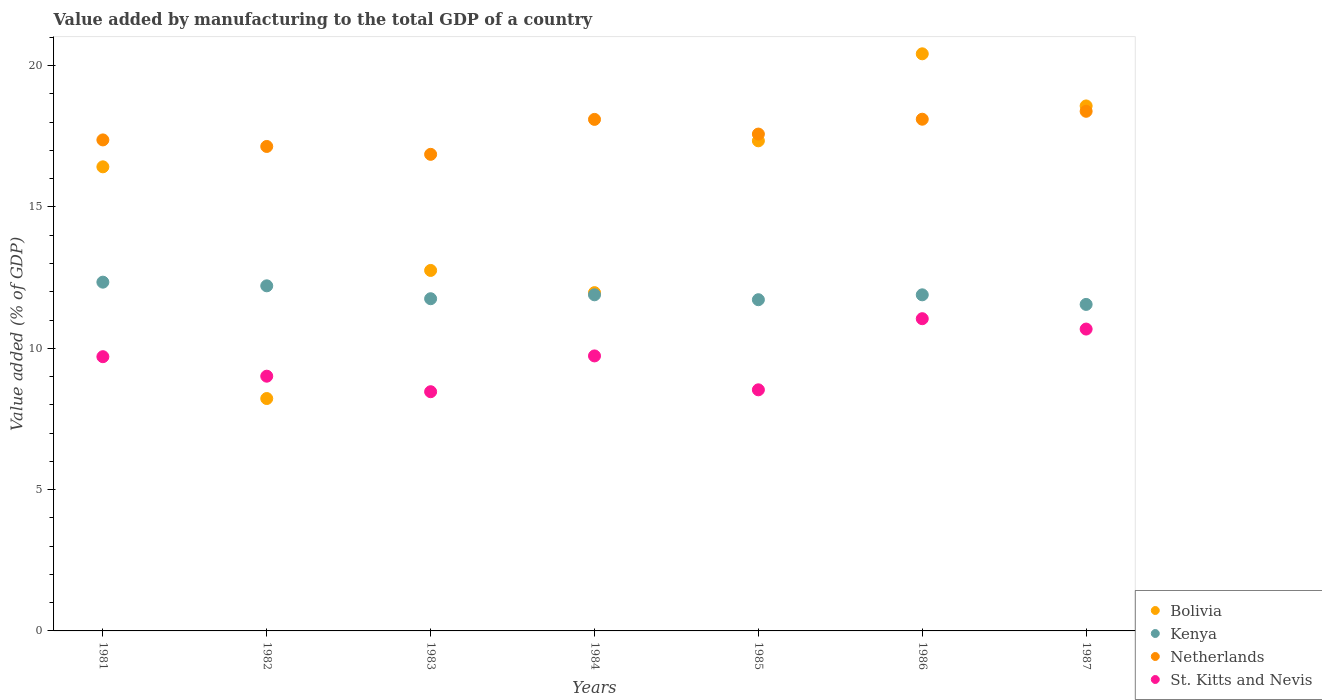How many different coloured dotlines are there?
Give a very brief answer. 4. Is the number of dotlines equal to the number of legend labels?
Make the answer very short. Yes. What is the value added by manufacturing to the total GDP in Kenya in 1986?
Offer a terse response. 11.89. Across all years, what is the maximum value added by manufacturing to the total GDP in Kenya?
Your answer should be compact. 12.34. Across all years, what is the minimum value added by manufacturing to the total GDP in Bolivia?
Offer a very short reply. 8.22. In which year was the value added by manufacturing to the total GDP in Netherlands maximum?
Your response must be concise. 1987. In which year was the value added by manufacturing to the total GDP in St. Kitts and Nevis minimum?
Ensure brevity in your answer.  1983. What is the total value added by manufacturing to the total GDP in Kenya in the graph?
Ensure brevity in your answer.  83.36. What is the difference between the value added by manufacturing to the total GDP in Netherlands in 1981 and that in 1982?
Your answer should be compact. 0.23. What is the difference between the value added by manufacturing to the total GDP in St. Kitts and Nevis in 1983 and the value added by manufacturing to the total GDP in Netherlands in 1986?
Offer a very short reply. -9.64. What is the average value added by manufacturing to the total GDP in Bolivia per year?
Your answer should be compact. 15.1. In the year 1983, what is the difference between the value added by manufacturing to the total GDP in Netherlands and value added by manufacturing to the total GDP in Kenya?
Your response must be concise. 5.11. In how many years, is the value added by manufacturing to the total GDP in Netherlands greater than 5 %?
Your answer should be very brief. 7. What is the ratio of the value added by manufacturing to the total GDP in Kenya in 1983 to that in 1985?
Give a very brief answer. 1. What is the difference between the highest and the second highest value added by manufacturing to the total GDP in Netherlands?
Keep it short and to the point. 0.28. What is the difference between the highest and the lowest value added by manufacturing to the total GDP in Bolivia?
Offer a terse response. 12.2. In how many years, is the value added by manufacturing to the total GDP in Kenya greater than the average value added by manufacturing to the total GDP in Kenya taken over all years?
Give a very brief answer. 2. Is it the case that in every year, the sum of the value added by manufacturing to the total GDP in St. Kitts and Nevis and value added by manufacturing to the total GDP in Bolivia  is greater than the sum of value added by manufacturing to the total GDP in Kenya and value added by manufacturing to the total GDP in Netherlands?
Provide a short and direct response. No. How many dotlines are there?
Provide a short and direct response. 4. How many years are there in the graph?
Offer a terse response. 7. Are the values on the major ticks of Y-axis written in scientific E-notation?
Offer a terse response. No. Does the graph contain any zero values?
Ensure brevity in your answer.  No. How many legend labels are there?
Provide a succinct answer. 4. What is the title of the graph?
Keep it short and to the point. Value added by manufacturing to the total GDP of a country. What is the label or title of the X-axis?
Give a very brief answer. Years. What is the label or title of the Y-axis?
Provide a succinct answer. Value added (% of GDP). What is the Value added (% of GDP) in Bolivia in 1981?
Provide a succinct answer. 16.42. What is the Value added (% of GDP) of Kenya in 1981?
Offer a terse response. 12.34. What is the Value added (% of GDP) in Netherlands in 1981?
Offer a very short reply. 17.37. What is the Value added (% of GDP) of St. Kitts and Nevis in 1981?
Your answer should be very brief. 9.7. What is the Value added (% of GDP) of Bolivia in 1982?
Ensure brevity in your answer.  8.22. What is the Value added (% of GDP) of Kenya in 1982?
Your answer should be very brief. 12.21. What is the Value added (% of GDP) of Netherlands in 1982?
Give a very brief answer. 17.14. What is the Value added (% of GDP) of St. Kitts and Nevis in 1982?
Provide a succinct answer. 9.01. What is the Value added (% of GDP) of Bolivia in 1983?
Provide a succinct answer. 12.75. What is the Value added (% of GDP) in Kenya in 1983?
Make the answer very short. 11.75. What is the Value added (% of GDP) of Netherlands in 1983?
Give a very brief answer. 16.86. What is the Value added (% of GDP) of St. Kitts and Nevis in 1983?
Your response must be concise. 8.46. What is the Value added (% of GDP) of Bolivia in 1984?
Offer a very short reply. 11.97. What is the Value added (% of GDP) in Kenya in 1984?
Your answer should be very brief. 11.89. What is the Value added (% of GDP) in Netherlands in 1984?
Make the answer very short. 18.1. What is the Value added (% of GDP) in St. Kitts and Nevis in 1984?
Your answer should be compact. 9.73. What is the Value added (% of GDP) of Bolivia in 1985?
Keep it short and to the point. 17.34. What is the Value added (% of GDP) of Kenya in 1985?
Give a very brief answer. 11.72. What is the Value added (% of GDP) of Netherlands in 1985?
Provide a succinct answer. 17.58. What is the Value added (% of GDP) in St. Kitts and Nevis in 1985?
Keep it short and to the point. 8.53. What is the Value added (% of GDP) in Bolivia in 1986?
Offer a very short reply. 20.42. What is the Value added (% of GDP) of Kenya in 1986?
Your answer should be very brief. 11.89. What is the Value added (% of GDP) in Netherlands in 1986?
Keep it short and to the point. 18.1. What is the Value added (% of GDP) in St. Kitts and Nevis in 1986?
Give a very brief answer. 11.05. What is the Value added (% of GDP) of Bolivia in 1987?
Offer a terse response. 18.57. What is the Value added (% of GDP) in Kenya in 1987?
Give a very brief answer. 11.55. What is the Value added (% of GDP) of Netherlands in 1987?
Ensure brevity in your answer.  18.38. What is the Value added (% of GDP) in St. Kitts and Nevis in 1987?
Your answer should be very brief. 10.68. Across all years, what is the maximum Value added (% of GDP) in Bolivia?
Your answer should be very brief. 20.42. Across all years, what is the maximum Value added (% of GDP) of Kenya?
Your answer should be very brief. 12.34. Across all years, what is the maximum Value added (% of GDP) in Netherlands?
Make the answer very short. 18.38. Across all years, what is the maximum Value added (% of GDP) of St. Kitts and Nevis?
Provide a succinct answer. 11.05. Across all years, what is the minimum Value added (% of GDP) of Bolivia?
Provide a succinct answer. 8.22. Across all years, what is the minimum Value added (% of GDP) in Kenya?
Offer a terse response. 11.55. Across all years, what is the minimum Value added (% of GDP) in Netherlands?
Your response must be concise. 16.86. Across all years, what is the minimum Value added (% of GDP) of St. Kitts and Nevis?
Your answer should be compact. 8.46. What is the total Value added (% of GDP) of Bolivia in the graph?
Your answer should be compact. 105.7. What is the total Value added (% of GDP) of Kenya in the graph?
Offer a very short reply. 83.36. What is the total Value added (% of GDP) in Netherlands in the graph?
Offer a terse response. 123.54. What is the total Value added (% of GDP) of St. Kitts and Nevis in the graph?
Offer a very short reply. 67.16. What is the difference between the Value added (% of GDP) in Bolivia in 1981 and that in 1982?
Your response must be concise. 8.2. What is the difference between the Value added (% of GDP) in Kenya in 1981 and that in 1982?
Provide a succinct answer. 0.13. What is the difference between the Value added (% of GDP) in Netherlands in 1981 and that in 1982?
Your response must be concise. 0.23. What is the difference between the Value added (% of GDP) of St. Kitts and Nevis in 1981 and that in 1982?
Offer a very short reply. 0.69. What is the difference between the Value added (% of GDP) of Bolivia in 1981 and that in 1983?
Your response must be concise. 3.67. What is the difference between the Value added (% of GDP) of Kenya in 1981 and that in 1983?
Provide a short and direct response. 0.59. What is the difference between the Value added (% of GDP) in Netherlands in 1981 and that in 1983?
Offer a very short reply. 0.51. What is the difference between the Value added (% of GDP) of St. Kitts and Nevis in 1981 and that in 1983?
Your answer should be compact. 1.24. What is the difference between the Value added (% of GDP) in Bolivia in 1981 and that in 1984?
Keep it short and to the point. 4.45. What is the difference between the Value added (% of GDP) in Kenya in 1981 and that in 1984?
Make the answer very short. 0.45. What is the difference between the Value added (% of GDP) in Netherlands in 1981 and that in 1984?
Your answer should be compact. -0.73. What is the difference between the Value added (% of GDP) in St. Kitts and Nevis in 1981 and that in 1984?
Ensure brevity in your answer.  -0.03. What is the difference between the Value added (% of GDP) in Bolivia in 1981 and that in 1985?
Provide a succinct answer. -0.92. What is the difference between the Value added (% of GDP) in Kenya in 1981 and that in 1985?
Your response must be concise. 0.62. What is the difference between the Value added (% of GDP) of Netherlands in 1981 and that in 1985?
Give a very brief answer. -0.21. What is the difference between the Value added (% of GDP) of St. Kitts and Nevis in 1981 and that in 1985?
Provide a succinct answer. 1.17. What is the difference between the Value added (% of GDP) of Bolivia in 1981 and that in 1986?
Your answer should be very brief. -4. What is the difference between the Value added (% of GDP) in Kenya in 1981 and that in 1986?
Ensure brevity in your answer.  0.45. What is the difference between the Value added (% of GDP) of Netherlands in 1981 and that in 1986?
Your answer should be very brief. -0.73. What is the difference between the Value added (% of GDP) of St. Kitts and Nevis in 1981 and that in 1986?
Your response must be concise. -1.34. What is the difference between the Value added (% of GDP) in Bolivia in 1981 and that in 1987?
Your answer should be very brief. -2.15. What is the difference between the Value added (% of GDP) of Kenya in 1981 and that in 1987?
Ensure brevity in your answer.  0.79. What is the difference between the Value added (% of GDP) of Netherlands in 1981 and that in 1987?
Offer a very short reply. -1.01. What is the difference between the Value added (% of GDP) in St. Kitts and Nevis in 1981 and that in 1987?
Provide a short and direct response. -0.98. What is the difference between the Value added (% of GDP) in Bolivia in 1982 and that in 1983?
Give a very brief answer. -4.53. What is the difference between the Value added (% of GDP) in Kenya in 1982 and that in 1983?
Ensure brevity in your answer.  0.46. What is the difference between the Value added (% of GDP) in Netherlands in 1982 and that in 1983?
Offer a terse response. 0.28. What is the difference between the Value added (% of GDP) in St. Kitts and Nevis in 1982 and that in 1983?
Make the answer very short. 0.55. What is the difference between the Value added (% of GDP) of Bolivia in 1982 and that in 1984?
Provide a succinct answer. -3.75. What is the difference between the Value added (% of GDP) in Kenya in 1982 and that in 1984?
Offer a very short reply. 0.32. What is the difference between the Value added (% of GDP) in Netherlands in 1982 and that in 1984?
Your answer should be very brief. -0.96. What is the difference between the Value added (% of GDP) in St. Kitts and Nevis in 1982 and that in 1984?
Your response must be concise. -0.72. What is the difference between the Value added (% of GDP) of Bolivia in 1982 and that in 1985?
Your response must be concise. -9.12. What is the difference between the Value added (% of GDP) in Kenya in 1982 and that in 1985?
Offer a very short reply. 0.49. What is the difference between the Value added (% of GDP) in Netherlands in 1982 and that in 1985?
Your response must be concise. -0.44. What is the difference between the Value added (% of GDP) of St. Kitts and Nevis in 1982 and that in 1985?
Make the answer very short. 0.48. What is the difference between the Value added (% of GDP) in Bolivia in 1982 and that in 1986?
Provide a short and direct response. -12.2. What is the difference between the Value added (% of GDP) of Kenya in 1982 and that in 1986?
Provide a short and direct response. 0.32. What is the difference between the Value added (% of GDP) in Netherlands in 1982 and that in 1986?
Your answer should be very brief. -0.96. What is the difference between the Value added (% of GDP) in St. Kitts and Nevis in 1982 and that in 1986?
Your answer should be compact. -2.03. What is the difference between the Value added (% of GDP) in Bolivia in 1982 and that in 1987?
Your answer should be very brief. -10.35. What is the difference between the Value added (% of GDP) in Kenya in 1982 and that in 1987?
Provide a succinct answer. 0.66. What is the difference between the Value added (% of GDP) of Netherlands in 1982 and that in 1987?
Your response must be concise. -1.24. What is the difference between the Value added (% of GDP) in St. Kitts and Nevis in 1982 and that in 1987?
Offer a very short reply. -1.67. What is the difference between the Value added (% of GDP) in Bolivia in 1983 and that in 1984?
Make the answer very short. 0.79. What is the difference between the Value added (% of GDP) in Kenya in 1983 and that in 1984?
Keep it short and to the point. -0.14. What is the difference between the Value added (% of GDP) in Netherlands in 1983 and that in 1984?
Provide a short and direct response. -1.24. What is the difference between the Value added (% of GDP) of St. Kitts and Nevis in 1983 and that in 1984?
Offer a terse response. -1.27. What is the difference between the Value added (% of GDP) in Bolivia in 1983 and that in 1985?
Your answer should be very brief. -4.59. What is the difference between the Value added (% of GDP) in Kenya in 1983 and that in 1985?
Keep it short and to the point. 0.04. What is the difference between the Value added (% of GDP) of Netherlands in 1983 and that in 1985?
Give a very brief answer. -0.72. What is the difference between the Value added (% of GDP) of St. Kitts and Nevis in 1983 and that in 1985?
Keep it short and to the point. -0.07. What is the difference between the Value added (% of GDP) of Bolivia in 1983 and that in 1986?
Your answer should be very brief. -7.66. What is the difference between the Value added (% of GDP) of Kenya in 1983 and that in 1986?
Provide a short and direct response. -0.14. What is the difference between the Value added (% of GDP) of Netherlands in 1983 and that in 1986?
Provide a short and direct response. -1.24. What is the difference between the Value added (% of GDP) of St. Kitts and Nevis in 1983 and that in 1986?
Make the answer very short. -2.58. What is the difference between the Value added (% of GDP) in Bolivia in 1983 and that in 1987?
Keep it short and to the point. -5.82. What is the difference between the Value added (% of GDP) of Kenya in 1983 and that in 1987?
Make the answer very short. 0.2. What is the difference between the Value added (% of GDP) of Netherlands in 1983 and that in 1987?
Make the answer very short. -1.52. What is the difference between the Value added (% of GDP) of St. Kitts and Nevis in 1983 and that in 1987?
Provide a short and direct response. -2.22. What is the difference between the Value added (% of GDP) in Bolivia in 1984 and that in 1985?
Provide a short and direct response. -5.37. What is the difference between the Value added (% of GDP) of Kenya in 1984 and that in 1985?
Keep it short and to the point. 0.17. What is the difference between the Value added (% of GDP) of Netherlands in 1984 and that in 1985?
Provide a succinct answer. 0.52. What is the difference between the Value added (% of GDP) of St. Kitts and Nevis in 1984 and that in 1985?
Provide a succinct answer. 1.2. What is the difference between the Value added (% of GDP) in Bolivia in 1984 and that in 1986?
Provide a succinct answer. -8.45. What is the difference between the Value added (% of GDP) in Kenya in 1984 and that in 1986?
Provide a succinct answer. 0. What is the difference between the Value added (% of GDP) of Netherlands in 1984 and that in 1986?
Give a very brief answer. -0.01. What is the difference between the Value added (% of GDP) of St. Kitts and Nevis in 1984 and that in 1986?
Ensure brevity in your answer.  -1.32. What is the difference between the Value added (% of GDP) in Bolivia in 1984 and that in 1987?
Your answer should be compact. -6.61. What is the difference between the Value added (% of GDP) of Kenya in 1984 and that in 1987?
Make the answer very short. 0.34. What is the difference between the Value added (% of GDP) of Netherlands in 1984 and that in 1987?
Your answer should be very brief. -0.29. What is the difference between the Value added (% of GDP) of St. Kitts and Nevis in 1984 and that in 1987?
Give a very brief answer. -0.95. What is the difference between the Value added (% of GDP) in Bolivia in 1985 and that in 1986?
Ensure brevity in your answer.  -3.08. What is the difference between the Value added (% of GDP) in Kenya in 1985 and that in 1986?
Offer a very short reply. -0.17. What is the difference between the Value added (% of GDP) in Netherlands in 1985 and that in 1986?
Your response must be concise. -0.53. What is the difference between the Value added (% of GDP) of St. Kitts and Nevis in 1985 and that in 1986?
Your response must be concise. -2.52. What is the difference between the Value added (% of GDP) of Bolivia in 1985 and that in 1987?
Provide a short and direct response. -1.23. What is the difference between the Value added (% of GDP) in Kenya in 1985 and that in 1987?
Provide a succinct answer. 0.17. What is the difference between the Value added (% of GDP) of Netherlands in 1985 and that in 1987?
Offer a terse response. -0.81. What is the difference between the Value added (% of GDP) of St. Kitts and Nevis in 1985 and that in 1987?
Your response must be concise. -2.15. What is the difference between the Value added (% of GDP) of Bolivia in 1986 and that in 1987?
Give a very brief answer. 1.84. What is the difference between the Value added (% of GDP) in Kenya in 1986 and that in 1987?
Ensure brevity in your answer.  0.34. What is the difference between the Value added (% of GDP) of Netherlands in 1986 and that in 1987?
Keep it short and to the point. -0.28. What is the difference between the Value added (% of GDP) in St. Kitts and Nevis in 1986 and that in 1987?
Keep it short and to the point. 0.37. What is the difference between the Value added (% of GDP) of Bolivia in 1981 and the Value added (% of GDP) of Kenya in 1982?
Ensure brevity in your answer.  4.21. What is the difference between the Value added (% of GDP) in Bolivia in 1981 and the Value added (% of GDP) in Netherlands in 1982?
Your answer should be very brief. -0.72. What is the difference between the Value added (% of GDP) in Bolivia in 1981 and the Value added (% of GDP) in St. Kitts and Nevis in 1982?
Your answer should be compact. 7.41. What is the difference between the Value added (% of GDP) of Kenya in 1981 and the Value added (% of GDP) of Netherlands in 1982?
Provide a succinct answer. -4.8. What is the difference between the Value added (% of GDP) in Kenya in 1981 and the Value added (% of GDP) in St. Kitts and Nevis in 1982?
Your answer should be compact. 3.33. What is the difference between the Value added (% of GDP) in Netherlands in 1981 and the Value added (% of GDP) in St. Kitts and Nevis in 1982?
Ensure brevity in your answer.  8.36. What is the difference between the Value added (% of GDP) in Bolivia in 1981 and the Value added (% of GDP) in Kenya in 1983?
Make the answer very short. 4.67. What is the difference between the Value added (% of GDP) in Bolivia in 1981 and the Value added (% of GDP) in Netherlands in 1983?
Give a very brief answer. -0.44. What is the difference between the Value added (% of GDP) in Bolivia in 1981 and the Value added (% of GDP) in St. Kitts and Nevis in 1983?
Ensure brevity in your answer.  7.96. What is the difference between the Value added (% of GDP) of Kenya in 1981 and the Value added (% of GDP) of Netherlands in 1983?
Give a very brief answer. -4.52. What is the difference between the Value added (% of GDP) of Kenya in 1981 and the Value added (% of GDP) of St. Kitts and Nevis in 1983?
Your answer should be compact. 3.88. What is the difference between the Value added (% of GDP) of Netherlands in 1981 and the Value added (% of GDP) of St. Kitts and Nevis in 1983?
Offer a terse response. 8.91. What is the difference between the Value added (% of GDP) of Bolivia in 1981 and the Value added (% of GDP) of Kenya in 1984?
Your response must be concise. 4.53. What is the difference between the Value added (% of GDP) of Bolivia in 1981 and the Value added (% of GDP) of Netherlands in 1984?
Make the answer very short. -1.68. What is the difference between the Value added (% of GDP) in Bolivia in 1981 and the Value added (% of GDP) in St. Kitts and Nevis in 1984?
Provide a succinct answer. 6.69. What is the difference between the Value added (% of GDP) of Kenya in 1981 and the Value added (% of GDP) of Netherlands in 1984?
Provide a short and direct response. -5.76. What is the difference between the Value added (% of GDP) of Kenya in 1981 and the Value added (% of GDP) of St. Kitts and Nevis in 1984?
Offer a terse response. 2.61. What is the difference between the Value added (% of GDP) of Netherlands in 1981 and the Value added (% of GDP) of St. Kitts and Nevis in 1984?
Your answer should be compact. 7.64. What is the difference between the Value added (% of GDP) in Bolivia in 1981 and the Value added (% of GDP) in Kenya in 1985?
Give a very brief answer. 4.7. What is the difference between the Value added (% of GDP) in Bolivia in 1981 and the Value added (% of GDP) in Netherlands in 1985?
Your response must be concise. -1.16. What is the difference between the Value added (% of GDP) of Bolivia in 1981 and the Value added (% of GDP) of St. Kitts and Nevis in 1985?
Provide a succinct answer. 7.89. What is the difference between the Value added (% of GDP) in Kenya in 1981 and the Value added (% of GDP) in Netherlands in 1985?
Provide a short and direct response. -5.24. What is the difference between the Value added (% of GDP) of Kenya in 1981 and the Value added (% of GDP) of St. Kitts and Nevis in 1985?
Your answer should be very brief. 3.81. What is the difference between the Value added (% of GDP) of Netherlands in 1981 and the Value added (% of GDP) of St. Kitts and Nevis in 1985?
Make the answer very short. 8.84. What is the difference between the Value added (% of GDP) of Bolivia in 1981 and the Value added (% of GDP) of Kenya in 1986?
Your answer should be very brief. 4.53. What is the difference between the Value added (% of GDP) in Bolivia in 1981 and the Value added (% of GDP) in Netherlands in 1986?
Your answer should be very brief. -1.68. What is the difference between the Value added (% of GDP) of Bolivia in 1981 and the Value added (% of GDP) of St. Kitts and Nevis in 1986?
Make the answer very short. 5.37. What is the difference between the Value added (% of GDP) of Kenya in 1981 and the Value added (% of GDP) of Netherlands in 1986?
Make the answer very short. -5.76. What is the difference between the Value added (% of GDP) of Kenya in 1981 and the Value added (% of GDP) of St. Kitts and Nevis in 1986?
Provide a short and direct response. 1.29. What is the difference between the Value added (% of GDP) of Netherlands in 1981 and the Value added (% of GDP) of St. Kitts and Nevis in 1986?
Your answer should be very brief. 6.33. What is the difference between the Value added (% of GDP) in Bolivia in 1981 and the Value added (% of GDP) in Kenya in 1987?
Make the answer very short. 4.87. What is the difference between the Value added (% of GDP) in Bolivia in 1981 and the Value added (% of GDP) in Netherlands in 1987?
Keep it short and to the point. -1.96. What is the difference between the Value added (% of GDP) of Bolivia in 1981 and the Value added (% of GDP) of St. Kitts and Nevis in 1987?
Your answer should be very brief. 5.74. What is the difference between the Value added (% of GDP) in Kenya in 1981 and the Value added (% of GDP) in Netherlands in 1987?
Provide a succinct answer. -6.05. What is the difference between the Value added (% of GDP) of Kenya in 1981 and the Value added (% of GDP) of St. Kitts and Nevis in 1987?
Give a very brief answer. 1.66. What is the difference between the Value added (% of GDP) of Netherlands in 1981 and the Value added (% of GDP) of St. Kitts and Nevis in 1987?
Ensure brevity in your answer.  6.69. What is the difference between the Value added (% of GDP) of Bolivia in 1982 and the Value added (% of GDP) of Kenya in 1983?
Your answer should be compact. -3.53. What is the difference between the Value added (% of GDP) in Bolivia in 1982 and the Value added (% of GDP) in Netherlands in 1983?
Provide a short and direct response. -8.64. What is the difference between the Value added (% of GDP) in Bolivia in 1982 and the Value added (% of GDP) in St. Kitts and Nevis in 1983?
Give a very brief answer. -0.24. What is the difference between the Value added (% of GDP) in Kenya in 1982 and the Value added (% of GDP) in Netherlands in 1983?
Provide a short and direct response. -4.65. What is the difference between the Value added (% of GDP) in Kenya in 1982 and the Value added (% of GDP) in St. Kitts and Nevis in 1983?
Offer a very short reply. 3.75. What is the difference between the Value added (% of GDP) of Netherlands in 1982 and the Value added (% of GDP) of St. Kitts and Nevis in 1983?
Provide a succinct answer. 8.68. What is the difference between the Value added (% of GDP) of Bolivia in 1982 and the Value added (% of GDP) of Kenya in 1984?
Your answer should be very brief. -3.67. What is the difference between the Value added (% of GDP) of Bolivia in 1982 and the Value added (% of GDP) of Netherlands in 1984?
Ensure brevity in your answer.  -9.88. What is the difference between the Value added (% of GDP) of Bolivia in 1982 and the Value added (% of GDP) of St. Kitts and Nevis in 1984?
Provide a short and direct response. -1.51. What is the difference between the Value added (% of GDP) of Kenya in 1982 and the Value added (% of GDP) of Netherlands in 1984?
Provide a succinct answer. -5.89. What is the difference between the Value added (% of GDP) in Kenya in 1982 and the Value added (% of GDP) in St. Kitts and Nevis in 1984?
Offer a very short reply. 2.48. What is the difference between the Value added (% of GDP) of Netherlands in 1982 and the Value added (% of GDP) of St. Kitts and Nevis in 1984?
Provide a succinct answer. 7.41. What is the difference between the Value added (% of GDP) in Bolivia in 1982 and the Value added (% of GDP) in Kenya in 1985?
Provide a succinct answer. -3.5. What is the difference between the Value added (% of GDP) in Bolivia in 1982 and the Value added (% of GDP) in Netherlands in 1985?
Ensure brevity in your answer.  -9.36. What is the difference between the Value added (% of GDP) of Bolivia in 1982 and the Value added (% of GDP) of St. Kitts and Nevis in 1985?
Offer a very short reply. -0.31. What is the difference between the Value added (% of GDP) in Kenya in 1982 and the Value added (% of GDP) in Netherlands in 1985?
Your answer should be very brief. -5.37. What is the difference between the Value added (% of GDP) of Kenya in 1982 and the Value added (% of GDP) of St. Kitts and Nevis in 1985?
Ensure brevity in your answer.  3.68. What is the difference between the Value added (% of GDP) of Netherlands in 1982 and the Value added (% of GDP) of St. Kitts and Nevis in 1985?
Provide a succinct answer. 8.61. What is the difference between the Value added (% of GDP) in Bolivia in 1982 and the Value added (% of GDP) in Kenya in 1986?
Keep it short and to the point. -3.67. What is the difference between the Value added (% of GDP) of Bolivia in 1982 and the Value added (% of GDP) of Netherlands in 1986?
Your response must be concise. -9.88. What is the difference between the Value added (% of GDP) of Bolivia in 1982 and the Value added (% of GDP) of St. Kitts and Nevis in 1986?
Your response must be concise. -2.82. What is the difference between the Value added (% of GDP) of Kenya in 1982 and the Value added (% of GDP) of Netherlands in 1986?
Give a very brief answer. -5.89. What is the difference between the Value added (% of GDP) in Kenya in 1982 and the Value added (% of GDP) in St. Kitts and Nevis in 1986?
Your answer should be compact. 1.16. What is the difference between the Value added (% of GDP) in Netherlands in 1982 and the Value added (% of GDP) in St. Kitts and Nevis in 1986?
Offer a terse response. 6.09. What is the difference between the Value added (% of GDP) of Bolivia in 1982 and the Value added (% of GDP) of Kenya in 1987?
Offer a very short reply. -3.33. What is the difference between the Value added (% of GDP) in Bolivia in 1982 and the Value added (% of GDP) in Netherlands in 1987?
Offer a very short reply. -10.16. What is the difference between the Value added (% of GDP) in Bolivia in 1982 and the Value added (% of GDP) in St. Kitts and Nevis in 1987?
Your answer should be compact. -2.46. What is the difference between the Value added (% of GDP) of Kenya in 1982 and the Value added (% of GDP) of Netherlands in 1987?
Provide a succinct answer. -6.17. What is the difference between the Value added (% of GDP) in Kenya in 1982 and the Value added (% of GDP) in St. Kitts and Nevis in 1987?
Your answer should be compact. 1.53. What is the difference between the Value added (% of GDP) in Netherlands in 1982 and the Value added (% of GDP) in St. Kitts and Nevis in 1987?
Your answer should be very brief. 6.46. What is the difference between the Value added (% of GDP) in Bolivia in 1983 and the Value added (% of GDP) in Kenya in 1984?
Provide a short and direct response. 0.86. What is the difference between the Value added (% of GDP) in Bolivia in 1983 and the Value added (% of GDP) in Netherlands in 1984?
Provide a succinct answer. -5.34. What is the difference between the Value added (% of GDP) in Bolivia in 1983 and the Value added (% of GDP) in St. Kitts and Nevis in 1984?
Give a very brief answer. 3.02. What is the difference between the Value added (% of GDP) of Kenya in 1983 and the Value added (% of GDP) of Netherlands in 1984?
Provide a succinct answer. -6.34. What is the difference between the Value added (% of GDP) of Kenya in 1983 and the Value added (% of GDP) of St. Kitts and Nevis in 1984?
Make the answer very short. 2.02. What is the difference between the Value added (% of GDP) of Netherlands in 1983 and the Value added (% of GDP) of St. Kitts and Nevis in 1984?
Keep it short and to the point. 7.13. What is the difference between the Value added (% of GDP) in Bolivia in 1983 and the Value added (% of GDP) in Kenya in 1985?
Make the answer very short. 1.04. What is the difference between the Value added (% of GDP) of Bolivia in 1983 and the Value added (% of GDP) of Netherlands in 1985?
Provide a short and direct response. -4.82. What is the difference between the Value added (% of GDP) of Bolivia in 1983 and the Value added (% of GDP) of St. Kitts and Nevis in 1985?
Keep it short and to the point. 4.22. What is the difference between the Value added (% of GDP) of Kenya in 1983 and the Value added (% of GDP) of Netherlands in 1985?
Give a very brief answer. -5.83. What is the difference between the Value added (% of GDP) of Kenya in 1983 and the Value added (% of GDP) of St. Kitts and Nevis in 1985?
Your answer should be compact. 3.22. What is the difference between the Value added (% of GDP) in Netherlands in 1983 and the Value added (% of GDP) in St. Kitts and Nevis in 1985?
Ensure brevity in your answer.  8.33. What is the difference between the Value added (% of GDP) of Bolivia in 1983 and the Value added (% of GDP) of Kenya in 1986?
Your response must be concise. 0.86. What is the difference between the Value added (% of GDP) of Bolivia in 1983 and the Value added (% of GDP) of Netherlands in 1986?
Keep it short and to the point. -5.35. What is the difference between the Value added (% of GDP) in Bolivia in 1983 and the Value added (% of GDP) in St. Kitts and Nevis in 1986?
Give a very brief answer. 1.71. What is the difference between the Value added (% of GDP) in Kenya in 1983 and the Value added (% of GDP) in Netherlands in 1986?
Ensure brevity in your answer.  -6.35. What is the difference between the Value added (% of GDP) in Kenya in 1983 and the Value added (% of GDP) in St. Kitts and Nevis in 1986?
Keep it short and to the point. 0.71. What is the difference between the Value added (% of GDP) in Netherlands in 1983 and the Value added (% of GDP) in St. Kitts and Nevis in 1986?
Give a very brief answer. 5.82. What is the difference between the Value added (% of GDP) in Bolivia in 1983 and the Value added (% of GDP) in Kenya in 1987?
Offer a very short reply. 1.2. What is the difference between the Value added (% of GDP) in Bolivia in 1983 and the Value added (% of GDP) in Netherlands in 1987?
Ensure brevity in your answer.  -5.63. What is the difference between the Value added (% of GDP) of Bolivia in 1983 and the Value added (% of GDP) of St. Kitts and Nevis in 1987?
Your response must be concise. 2.07. What is the difference between the Value added (% of GDP) of Kenya in 1983 and the Value added (% of GDP) of Netherlands in 1987?
Make the answer very short. -6.63. What is the difference between the Value added (% of GDP) in Kenya in 1983 and the Value added (% of GDP) in St. Kitts and Nevis in 1987?
Provide a short and direct response. 1.07. What is the difference between the Value added (% of GDP) in Netherlands in 1983 and the Value added (% of GDP) in St. Kitts and Nevis in 1987?
Make the answer very short. 6.18. What is the difference between the Value added (% of GDP) in Bolivia in 1984 and the Value added (% of GDP) in Kenya in 1985?
Your answer should be compact. 0.25. What is the difference between the Value added (% of GDP) of Bolivia in 1984 and the Value added (% of GDP) of Netherlands in 1985?
Your answer should be compact. -5.61. What is the difference between the Value added (% of GDP) in Bolivia in 1984 and the Value added (% of GDP) in St. Kitts and Nevis in 1985?
Your answer should be compact. 3.44. What is the difference between the Value added (% of GDP) of Kenya in 1984 and the Value added (% of GDP) of Netherlands in 1985?
Ensure brevity in your answer.  -5.69. What is the difference between the Value added (% of GDP) of Kenya in 1984 and the Value added (% of GDP) of St. Kitts and Nevis in 1985?
Your response must be concise. 3.36. What is the difference between the Value added (% of GDP) in Netherlands in 1984 and the Value added (% of GDP) in St. Kitts and Nevis in 1985?
Keep it short and to the point. 9.57. What is the difference between the Value added (% of GDP) of Bolivia in 1984 and the Value added (% of GDP) of Kenya in 1986?
Give a very brief answer. 0.08. What is the difference between the Value added (% of GDP) of Bolivia in 1984 and the Value added (% of GDP) of Netherlands in 1986?
Your answer should be compact. -6.14. What is the difference between the Value added (% of GDP) of Bolivia in 1984 and the Value added (% of GDP) of St. Kitts and Nevis in 1986?
Ensure brevity in your answer.  0.92. What is the difference between the Value added (% of GDP) of Kenya in 1984 and the Value added (% of GDP) of Netherlands in 1986?
Your response must be concise. -6.21. What is the difference between the Value added (% of GDP) in Kenya in 1984 and the Value added (% of GDP) in St. Kitts and Nevis in 1986?
Provide a succinct answer. 0.85. What is the difference between the Value added (% of GDP) in Netherlands in 1984 and the Value added (% of GDP) in St. Kitts and Nevis in 1986?
Ensure brevity in your answer.  7.05. What is the difference between the Value added (% of GDP) of Bolivia in 1984 and the Value added (% of GDP) of Kenya in 1987?
Keep it short and to the point. 0.42. What is the difference between the Value added (% of GDP) of Bolivia in 1984 and the Value added (% of GDP) of Netherlands in 1987?
Your answer should be very brief. -6.42. What is the difference between the Value added (% of GDP) in Bolivia in 1984 and the Value added (% of GDP) in St. Kitts and Nevis in 1987?
Offer a very short reply. 1.29. What is the difference between the Value added (% of GDP) in Kenya in 1984 and the Value added (% of GDP) in Netherlands in 1987?
Keep it short and to the point. -6.49. What is the difference between the Value added (% of GDP) in Kenya in 1984 and the Value added (% of GDP) in St. Kitts and Nevis in 1987?
Your answer should be compact. 1.21. What is the difference between the Value added (% of GDP) in Netherlands in 1984 and the Value added (% of GDP) in St. Kitts and Nevis in 1987?
Provide a short and direct response. 7.42. What is the difference between the Value added (% of GDP) in Bolivia in 1985 and the Value added (% of GDP) in Kenya in 1986?
Offer a terse response. 5.45. What is the difference between the Value added (% of GDP) of Bolivia in 1985 and the Value added (% of GDP) of Netherlands in 1986?
Your response must be concise. -0.76. What is the difference between the Value added (% of GDP) of Bolivia in 1985 and the Value added (% of GDP) of St. Kitts and Nevis in 1986?
Offer a very short reply. 6.29. What is the difference between the Value added (% of GDP) of Kenya in 1985 and the Value added (% of GDP) of Netherlands in 1986?
Your answer should be compact. -6.39. What is the difference between the Value added (% of GDP) in Kenya in 1985 and the Value added (% of GDP) in St. Kitts and Nevis in 1986?
Provide a short and direct response. 0.67. What is the difference between the Value added (% of GDP) in Netherlands in 1985 and the Value added (% of GDP) in St. Kitts and Nevis in 1986?
Provide a short and direct response. 6.53. What is the difference between the Value added (% of GDP) of Bolivia in 1985 and the Value added (% of GDP) of Kenya in 1987?
Your answer should be compact. 5.79. What is the difference between the Value added (% of GDP) of Bolivia in 1985 and the Value added (% of GDP) of Netherlands in 1987?
Give a very brief answer. -1.04. What is the difference between the Value added (% of GDP) of Bolivia in 1985 and the Value added (% of GDP) of St. Kitts and Nevis in 1987?
Make the answer very short. 6.66. What is the difference between the Value added (% of GDP) of Kenya in 1985 and the Value added (% of GDP) of Netherlands in 1987?
Your answer should be very brief. -6.67. What is the difference between the Value added (% of GDP) in Kenya in 1985 and the Value added (% of GDP) in St. Kitts and Nevis in 1987?
Ensure brevity in your answer.  1.04. What is the difference between the Value added (% of GDP) in Netherlands in 1985 and the Value added (% of GDP) in St. Kitts and Nevis in 1987?
Ensure brevity in your answer.  6.9. What is the difference between the Value added (% of GDP) in Bolivia in 1986 and the Value added (% of GDP) in Kenya in 1987?
Make the answer very short. 8.87. What is the difference between the Value added (% of GDP) in Bolivia in 1986 and the Value added (% of GDP) in Netherlands in 1987?
Make the answer very short. 2.03. What is the difference between the Value added (% of GDP) of Bolivia in 1986 and the Value added (% of GDP) of St. Kitts and Nevis in 1987?
Your answer should be very brief. 9.74. What is the difference between the Value added (% of GDP) in Kenya in 1986 and the Value added (% of GDP) in Netherlands in 1987?
Your answer should be compact. -6.49. What is the difference between the Value added (% of GDP) in Kenya in 1986 and the Value added (% of GDP) in St. Kitts and Nevis in 1987?
Give a very brief answer. 1.21. What is the difference between the Value added (% of GDP) in Netherlands in 1986 and the Value added (% of GDP) in St. Kitts and Nevis in 1987?
Make the answer very short. 7.42. What is the average Value added (% of GDP) of Bolivia per year?
Your response must be concise. 15.1. What is the average Value added (% of GDP) in Kenya per year?
Your response must be concise. 11.91. What is the average Value added (% of GDP) of Netherlands per year?
Provide a short and direct response. 17.65. What is the average Value added (% of GDP) in St. Kitts and Nevis per year?
Provide a short and direct response. 9.59. In the year 1981, what is the difference between the Value added (% of GDP) of Bolivia and Value added (% of GDP) of Kenya?
Give a very brief answer. 4.08. In the year 1981, what is the difference between the Value added (% of GDP) in Bolivia and Value added (% of GDP) in Netherlands?
Your answer should be compact. -0.95. In the year 1981, what is the difference between the Value added (% of GDP) of Bolivia and Value added (% of GDP) of St. Kitts and Nevis?
Your answer should be very brief. 6.72. In the year 1981, what is the difference between the Value added (% of GDP) of Kenya and Value added (% of GDP) of Netherlands?
Offer a very short reply. -5.03. In the year 1981, what is the difference between the Value added (% of GDP) of Kenya and Value added (% of GDP) of St. Kitts and Nevis?
Your response must be concise. 2.64. In the year 1981, what is the difference between the Value added (% of GDP) in Netherlands and Value added (% of GDP) in St. Kitts and Nevis?
Your answer should be very brief. 7.67. In the year 1982, what is the difference between the Value added (% of GDP) in Bolivia and Value added (% of GDP) in Kenya?
Provide a succinct answer. -3.99. In the year 1982, what is the difference between the Value added (% of GDP) in Bolivia and Value added (% of GDP) in Netherlands?
Your answer should be very brief. -8.92. In the year 1982, what is the difference between the Value added (% of GDP) in Bolivia and Value added (% of GDP) in St. Kitts and Nevis?
Your answer should be very brief. -0.79. In the year 1982, what is the difference between the Value added (% of GDP) of Kenya and Value added (% of GDP) of Netherlands?
Offer a terse response. -4.93. In the year 1982, what is the difference between the Value added (% of GDP) in Kenya and Value added (% of GDP) in St. Kitts and Nevis?
Provide a succinct answer. 3.2. In the year 1982, what is the difference between the Value added (% of GDP) in Netherlands and Value added (% of GDP) in St. Kitts and Nevis?
Your answer should be compact. 8.13. In the year 1983, what is the difference between the Value added (% of GDP) of Bolivia and Value added (% of GDP) of Kenya?
Make the answer very short. 1. In the year 1983, what is the difference between the Value added (% of GDP) of Bolivia and Value added (% of GDP) of Netherlands?
Make the answer very short. -4.11. In the year 1983, what is the difference between the Value added (% of GDP) of Bolivia and Value added (% of GDP) of St. Kitts and Nevis?
Your response must be concise. 4.29. In the year 1983, what is the difference between the Value added (% of GDP) in Kenya and Value added (% of GDP) in Netherlands?
Your answer should be compact. -5.11. In the year 1983, what is the difference between the Value added (% of GDP) of Kenya and Value added (% of GDP) of St. Kitts and Nevis?
Offer a very short reply. 3.29. In the year 1983, what is the difference between the Value added (% of GDP) in Netherlands and Value added (% of GDP) in St. Kitts and Nevis?
Give a very brief answer. 8.4. In the year 1984, what is the difference between the Value added (% of GDP) in Bolivia and Value added (% of GDP) in Kenya?
Your answer should be very brief. 0.08. In the year 1984, what is the difference between the Value added (% of GDP) of Bolivia and Value added (% of GDP) of Netherlands?
Offer a terse response. -6.13. In the year 1984, what is the difference between the Value added (% of GDP) of Bolivia and Value added (% of GDP) of St. Kitts and Nevis?
Offer a very short reply. 2.24. In the year 1984, what is the difference between the Value added (% of GDP) in Kenya and Value added (% of GDP) in Netherlands?
Provide a short and direct response. -6.21. In the year 1984, what is the difference between the Value added (% of GDP) in Kenya and Value added (% of GDP) in St. Kitts and Nevis?
Ensure brevity in your answer.  2.16. In the year 1984, what is the difference between the Value added (% of GDP) of Netherlands and Value added (% of GDP) of St. Kitts and Nevis?
Offer a very short reply. 8.37. In the year 1985, what is the difference between the Value added (% of GDP) of Bolivia and Value added (% of GDP) of Kenya?
Provide a succinct answer. 5.62. In the year 1985, what is the difference between the Value added (% of GDP) of Bolivia and Value added (% of GDP) of Netherlands?
Keep it short and to the point. -0.24. In the year 1985, what is the difference between the Value added (% of GDP) of Bolivia and Value added (% of GDP) of St. Kitts and Nevis?
Your response must be concise. 8.81. In the year 1985, what is the difference between the Value added (% of GDP) of Kenya and Value added (% of GDP) of Netherlands?
Ensure brevity in your answer.  -5.86. In the year 1985, what is the difference between the Value added (% of GDP) of Kenya and Value added (% of GDP) of St. Kitts and Nevis?
Keep it short and to the point. 3.19. In the year 1985, what is the difference between the Value added (% of GDP) of Netherlands and Value added (% of GDP) of St. Kitts and Nevis?
Your answer should be compact. 9.05. In the year 1986, what is the difference between the Value added (% of GDP) in Bolivia and Value added (% of GDP) in Kenya?
Ensure brevity in your answer.  8.53. In the year 1986, what is the difference between the Value added (% of GDP) in Bolivia and Value added (% of GDP) in Netherlands?
Give a very brief answer. 2.31. In the year 1986, what is the difference between the Value added (% of GDP) in Bolivia and Value added (% of GDP) in St. Kitts and Nevis?
Offer a very short reply. 9.37. In the year 1986, what is the difference between the Value added (% of GDP) in Kenya and Value added (% of GDP) in Netherlands?
Your response must be concise. -6.21. In the year 1986, what is the difference between the Value added (% of GDP) in Kenya and Value added (% of GDP) in St. Kitts and Nevis?
Give a very brief answer. 0.84. In the year 1986, what is the difference between the Value added (% of GDP) in Netherlands and Value added (% of GDP) in St. Kitts and Nevis?
Keep it short and to the point. 7.06. In the year 1987, what is the difference between the Value added (% of GDP) of Bolivia and Value added (% of GDP) of Kenya?
Offer a terse response. 7.02. In the year 1987, what is the difference between the Value added (% of GDP) of Bolivia and Value added (% of GDP) of Netherlands?
Keep it short and to the point. 0.19. In the year 1987, what is the difference between the Value added (% of GDP) in Bolivia and Value added (% of GDP) in St. Kitts and Nevis?
Your answer should be very brief. 7.89. In the year 1987, what is the difference between the Value added (% of GDP) of Kenya and Value added (% of GDP) of Netherlands?
Your answer should be compact. -6.83. In the year 1987, what is the difference between the Value added (% of GDP) of Kenya and Value added (% of GDP) of St. Kitts and Nevis?
Offer a very short reply. 0.87. In the year 1987, what is the difference between the Value added (% of GDP) in Netherlands and Value added (% of GDP) in St. Kitts and Nevis?
Ensure brevity in your answer.  7.7. What is the ratio of the Value added (% of GDP) in Bolivia in 1981 to that in 1982?
Ensure brevity in your answer.  2. What is the ratio of the Value added (% of GDP) in Kenya in 1981 to that in 1982?
Give a very brief answer. 1.01. What is the ratio of the Value added (% of GDP) in Netherlands in 1981 to that in 1982?
Give a very brief answer. 1.01. What is the ratio of the Value added (% of GDP) in St. Kitts and Nevis in 1981 to that in 1982?
Make the answer very short. 1.08. What is the ratio of the Value added (% of GDP) of Bolivia in 1981 to that in 1983?
Keep it short and to the point. 1.29. What is the ratio of the Value added (% of GDP) in Kenya in 1981 to that in 1983?
Ensure brevity in your answer.  1.05. What is the ratio of the Value added (% of GDP) of Netherlands in 1981 to that in 1983?
Make the answer very short. 1.03. What is the ratio of the Value added (% of GDP) of St. Kitts and Nevis in 1981 to that in 1983?
Your response must be concise. 1.15. What is the ratio of the Value added (% of GDP) of Bolivia in 1981 to that in 1984?
Keep it short and to the point. 1.37. What is the ratio of the Value added (% of GDP) in Kenya in 1981 to that in 1984?
Your answer should be compact. 1.04. What is the ratio of the Value added (% of GDP) in Netherlands in 1981 to that in 1984?
Your answer should be compact. 0.96. What is the ratio of the Value added (% of GDP) of Bolivia in 1981 to that in 1985?
Your response must be concise. 0.95. What is the ratio of the Value added (% of GDP) of Kenya in 1981 to that in 1985?
Your answer should be compact. 1.05. What is the ratio of the Value added (% of GDP) in Netherlands in 1981 to that in 1985?
Offer a very short reply. 0.99. What is the ratio of the Value added (% of GDP) of St. Kitts and Nevis in 1981 to that in 1985?
Keep it short and to the point. 1.14. What is the ratio of the Value added (% of GDP) in Bolivia in 1981 to that in 1986?
Offer a very short reply. 0.8. What is the ratio of the Value added (% of GDP) of Kenya in 1981 to that in 1986?
Your answer should be very brief. 1.04. What is the ratio of the Value added (% of GDP) of Netherlands in 1981 to that in 1986?
Provide a short and direct response. 0.96. What is the ratio of the Value added (% of GDP) in St. Kitts and Nevis in 1981 to that in 1986?
Keep it short and to the point. 0.88. What is the ratio of the Value added (% of GDP) of Bolivia in 1981 to that in 1987?
Ensure brevity in your answer.  0.88. What is the ratio of the Value added (% of GDP) of Kenya in 1981 to that in 1987?
Offer a terse response. 1.07. What is the ratio of the Value added (% of GDP) in Netherlands in 1981 to that in 1987?
Ensure brevity in your answer.  0.94. What is the ratio of the Value added (% of GDP) of St. Kitts and Nevis in 1981 to that in 1987?
Keep it short and to the point. 0.91. What is the ratio of the Value added (% of GDP) of Bolivia in 1982 to that in 1983?
Keep it short and to the point. 0.64. What is the ratio of the Value added (% of GDP) of Kenya in 1982 to that in 1983?
Your answer should be compact. 1.04. What is the ratio of the Value added (% of GDP) in Netherlands in 1982 to that in 1983?
Your response must be concise. 1.02. What is the ratio of the Value added (% of GDP) of St. Kitts and Nevis in 1982 to that in 1983?
Your response must be concise. 1.06. What is the ratio of the Value added (% of GDP) in Bolivia in 1982 to that in 1984?
Offer a very short reply. 0.69. What is the ratio of the Value added (% of GDP) in Kenya in 1982 to that in 1984?
Provide a succinct answer. 1.03. What is the ratio of the Value added (% of GDP) of Netherlands in 1982 to that in 1984?
Keep it short and to the point. 0.95. What is the ratio of the Value added (% of GDP) of St. Kitts and Nevis in 1982 to that in 1984?
Provide a short and direct response. 0.93. What is the ratio of the Value added (% of GDP) of Bolivia in 1982 to that in 1985?
Offer a very short reply. 0.47. What is the ratio of the Value added (% of GDP) in Kenya in 1982 to that in 1985?
Make the answer very short. 1.04. What is the ratio of the Value added (% of GDP) of Netherlands in 1982 to that in 1985?
Give a very brief answer. 0.98. What is the ratio of the Value added (% of GDP) in St. Kitts and Nevis in 1982 to that in 1985?
Provide a succinct answer. 1.06. What is the ratio of the Value added (% of GDP) in Bolivia in 1982 to that in 1986?
Your answer should be very brief. 0.4. What is the ratio of the Value added (% of GDP) of Kenya in 1982 to that in 1986?
Ensure brevity in your answer.  1.03. What is the ratio of the Value added (% of GDP) in Netherlands in 1982 to that in 1986?
Provide a short and direct response. 0.95. What is the ratio of the Value added (% of GDP) in St. Kitts and Nevis in 1982 to that in 1986?
Provide a short and direct response. 0.82. What is the ratio of the Value added (% of GDP) in Bolivia in 1982 to that in 1987?
Give a very brief answer. 0.44. What is the ratio of the Value added (% of GDP) of Kenya in 1982 to that in 1987?
Provide a succinct answer. 1.06. What is the ratio of the Value added (% of GDP) of Netherlands in 1982 to that in 1987?
Provide a short and direct response. 0.93. What is the ratio of the Value added (% of GDP) in St. Kitts and Nevis in 1982 to that in 1987?
Ensure brevity in your answer.  0.84. What is the ratio of the Value added (% of GDP) in Bolivia in 1983 to that in 1984?
Keep it short and to the point. 1.07. What is the ratio of the Value added (% of GDP) in Kenya in 1983 to that in 1984?
Provide a short and direct response. 0.99. What is the ratio of the Value added (% of GDP) of Netherlands in 1983 to that in 1984?
Ensure brevity in your answer.  0.93. What is the ratio of the Value added (% of GDP) of St. Kitts and Nevis in 1983 to that in 1984?
Offer a very short reply. 0.87. What is the ratio of the Value added (% of GDP) in Bolivia in 1983 to that in 1985?
Offer a terse response. 0.74. What is the ratio of the Value added (% of GDP) in Netherlands in 1983 to that in 1985?
Keep it short and to the point. 0.96. What is the ratio of the Value added (% of GDP) in St. Kitts and Nevis in 1983 to that in 1985?
Offer a terse response. 0.99. What is the ratio of the Value added (% of GDP) in Bolivia in 1983 to that in 1986?
Give a very brief answer. 0.62. What is the ratio of the Value added (% of GDP) in Kenya in 1983 to that in 1986?
Offer a terse response. 0.99. What is the ratio of the Value added (% of GDP) in Netherlands in 1983 to that in 1986?
Provide a succinct answer. 0.93. What is the ratio of the Value added (% of GDP) in St. Kitts and Nevis in 1983 to that in 1986?
Give a very brief answer. 0.77. What is the ratio of the Value added (% of GDP) in Bolivia in 1983 to that in 1987?
Provide a short and direct response. 0.69. What is the ratio of the Value added (% of GDP) in Kenya in 1983 to that in 1987?
Offer a very short reply. 1.02. What is the ratio of the Value added (% of GDP) of Netherlands in 1983 to that in 1987?
Provide a succinct answer. 0.92. What is the ratio of the Value added (% of GDP) of St. Kitts and Nevis in 1983 to that in 1987?
Your response must be concise. 0.79. What is the ratio of the Value added (% of GDP) of Bolivia in 1984 to that in 1985?
Your answer should be compact. 0.69. What is the ratio of the Value added (% of GDP) of Kenya in 1984 to that in 1985?
Offer a very short reply. 1.01. What is the ratio of the Value added (% of GDP) of Netherlands in 1984 to that in 1985?
Give a very brief answer. 1.03. What is the ratio of the Value added (% of GDP) of St. Kitts and Nevis in 1984 to that in 1985?
Ensure brevity in your answer.  1.14. What is the ratio of the Value added (% of GDP) of Bolivia in 1984 to that in 1986?
Offer a terse response. 0.59. What is the ratio of the Value added (% of GDP) of Netherlands in 1984 to that in 1986?
Provide a succinct answer. 1. What is the ratio of the Value added (% of GDP) in St. Kitts and Nevis in 1984 to that in 1986?
Offer a terse response. 0.88. What is the ratio of the Value added (% of GDP) in Bolivia in 1984 to that in 1987?
Make the answer very short. 0.64. What is the ratio of the Value added (% of GDP) in Kenya in 1984 to that in 1987?
Provide a short and direct response. 1.03. What is the ratio of the Value added (% of GDP) of Netherlands in 1984 to that in 1987?
Your answer should be very brief. 0.98. What is the ratio of the Value added (% of GDP) in St. Kitts and Nevis in 1984 to that in 1987?
Your response must be concise. 0.91. What is the ratio of the Value added (% of GDP) of Bolivia in 1985 to that in 1986?
Ensure brevity in your answer.  0.85. What is the ratio of the Value added (% of GDP) in Kenya in 1985 to that in 1986?
Provide a succinct answer. 0.99. What is the ratio of the Value added (% of GDP) of St. Kitts and Nevis in 1985 to that in 1986?
Offer a very short reply. 0.77. What is the ratio of the Value added (% of GDP) of Bolivia in 1985 to that in 1987?
Give a very brief answer. 0.93. What is the ratio of the Value added (% of GDP) in Kenya in 1985 to that in 1987?
Provide a short and direct response. 1.01. What is the ratio of the Value added (% of GDP) in Netherlands in 1985 to that in 1987?
Offer a very short reply. 0.96. What is the ratio of the Value added (% of GDP) in St. Kitts and Nevis in 1985 to that in 1987?
Give a very brief answer. 0.8. What is the ratio of the Value added (% of GDP) in Bolivia in 1986 to that in 1987?
Your answer should be compact. 1.1. What is the ratio of the Value added (% of GDP) of Kenya in 1986 to that in 1987?
Offer a very short reply. 1.03. What is the ratio of the Value added (% of GDP) in St. Kitts and Nevis in 1986 to that in 1987?
Provide a succinct answer. 1.03. What is the difference between the highest and the second highest Value added (% of GDP) in Bolivia?
Offer a terse response. 1.84. What is the difference between the highest and the second highest Value added (% of GDP) of Kenya?
Offer a very short reply. 0.13. What is the difference between the highest and the second highest Value added (% of GDP) in Netherlands?
Give a very brief answer. 0.28. What is the difference between the highest and the second highest Value added (% of GDP) of St. Kitts and Nevis?
Your answer should be very brief. 0.37. What is the difference between the highest and the lowest Value added (% of GDP) in Bolivia?
Provide a succinct answer. 12.2. What is the difference between the highest and the lowest Value added (% of GDP) in Kenya?
Your response must be concise. 0.79. What is the difference between the highest and the lowest Value added (% of GDP) of Netherlands?
Ensure brevity in your answer.  1.52. What is the difference between the highest and the lowest Value added (% of GDP) of St. Kitts and Nevis?
Your response must be concise. 2.58. 